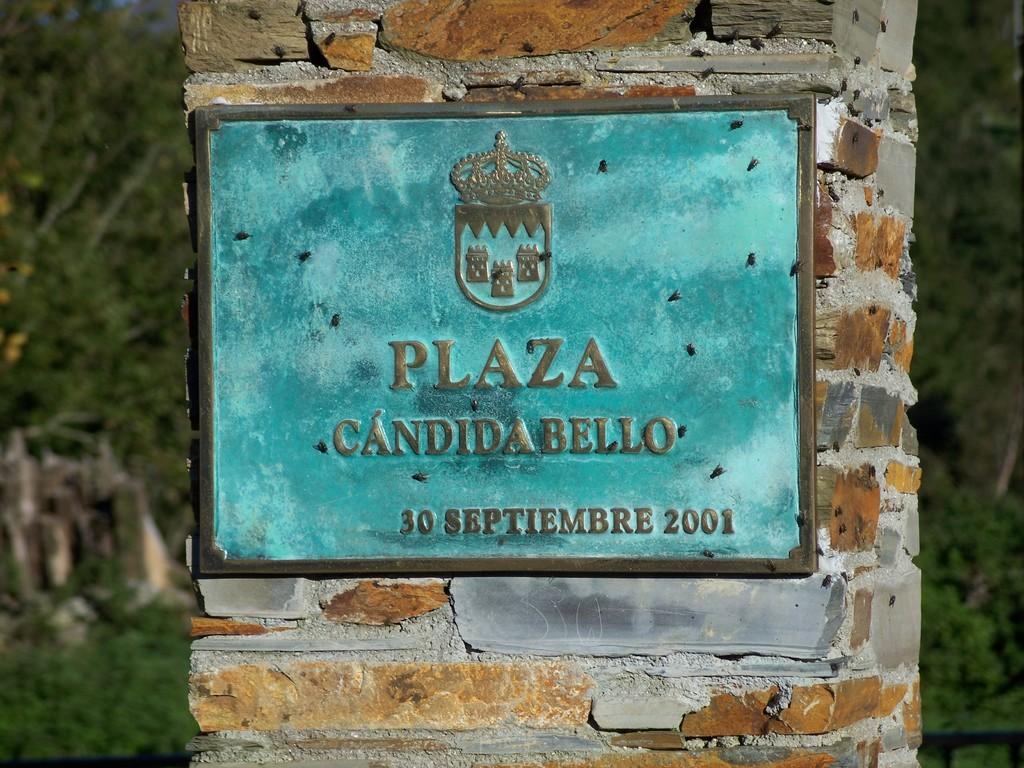What is attached to the wall in the image? There is a frame attached to the wall in the image. What can be seen behind the frame? Trees are visible behind the frame. What type of letter is being delivered by the fowl in the image? There is no fowl or letter present in the image; it only features a frame attached to the wall and trees in the background. 